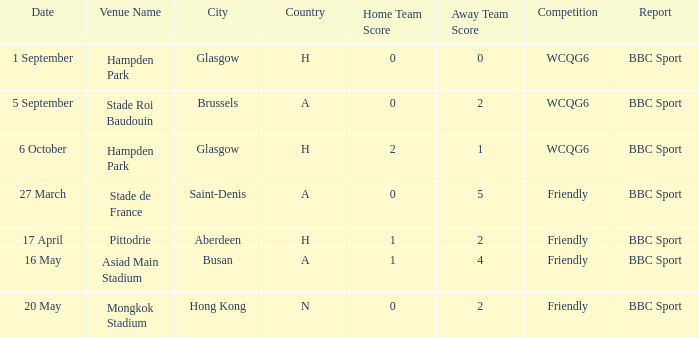Who reported the game played on 1 september? BBC Sport. 